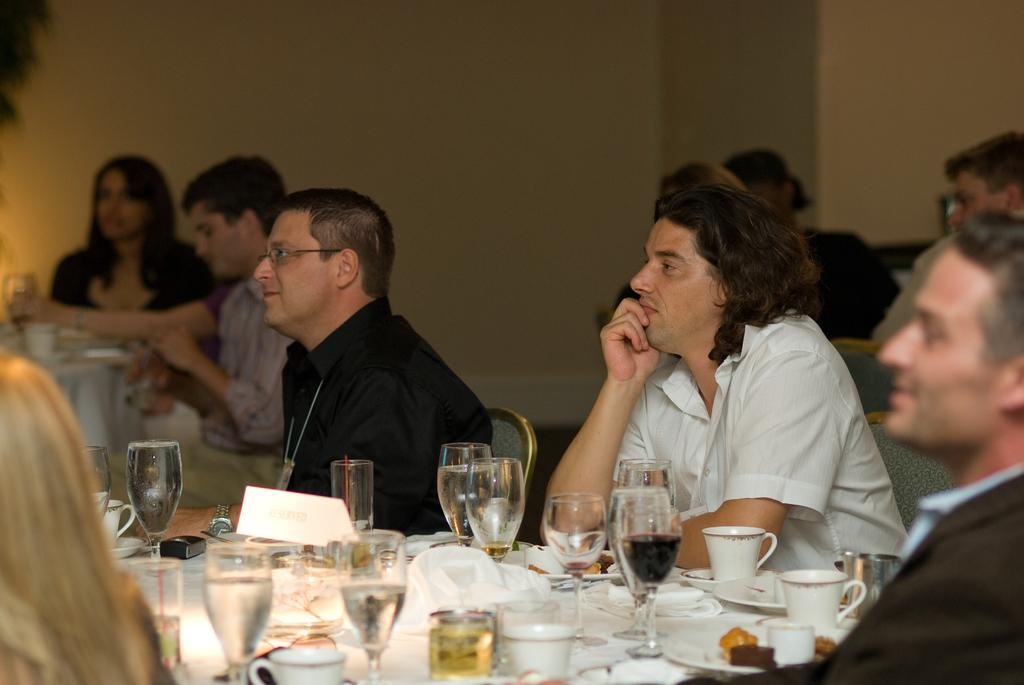What are the people in the image doing? The people in the image are sitting in chairs around the tables. What can be seen on the tables? Glasses, cups, food on plates, napkins, and beverages are present on the tables. Are there any other objects on the tables? Yes, there are other objects on the tables. Can you see a kite flying over the edge of the table in the image? No, there is no kite or edge of a table present in the image. 